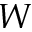Convert formula to latex. <formula><loc_0><loc_0><loc_500><loc_500>W</formula> 